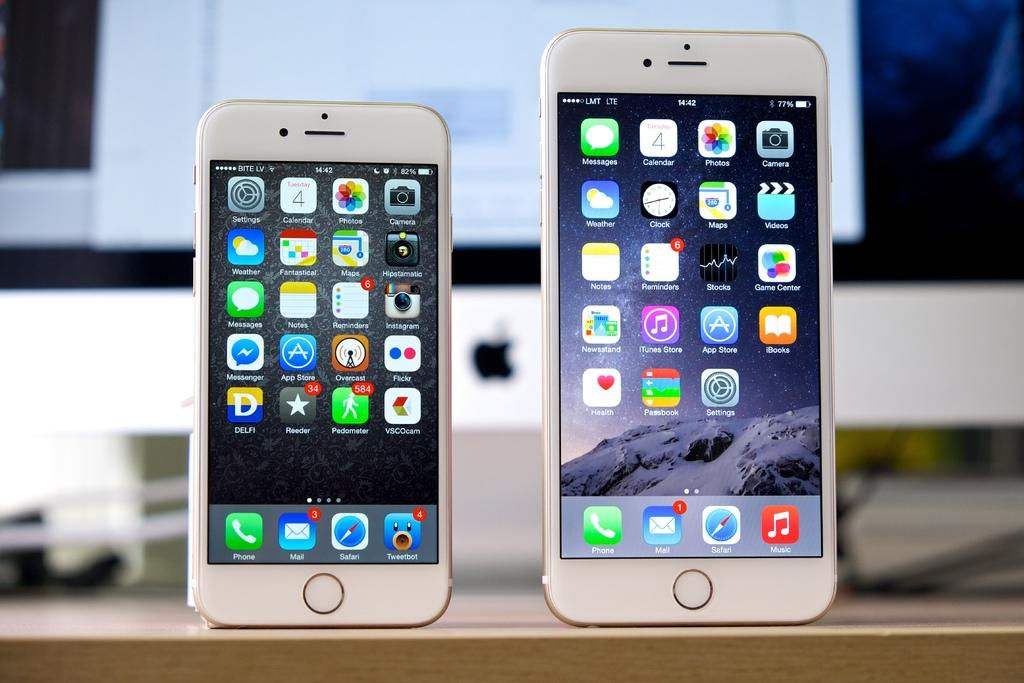<image>
Give a short and clear explanation of the subsequent image. Two different Apple iPhones stand next to each other displaying various apps such as Safari, Photos, App Store, iTunes Store, Flickr, and Passbook. 